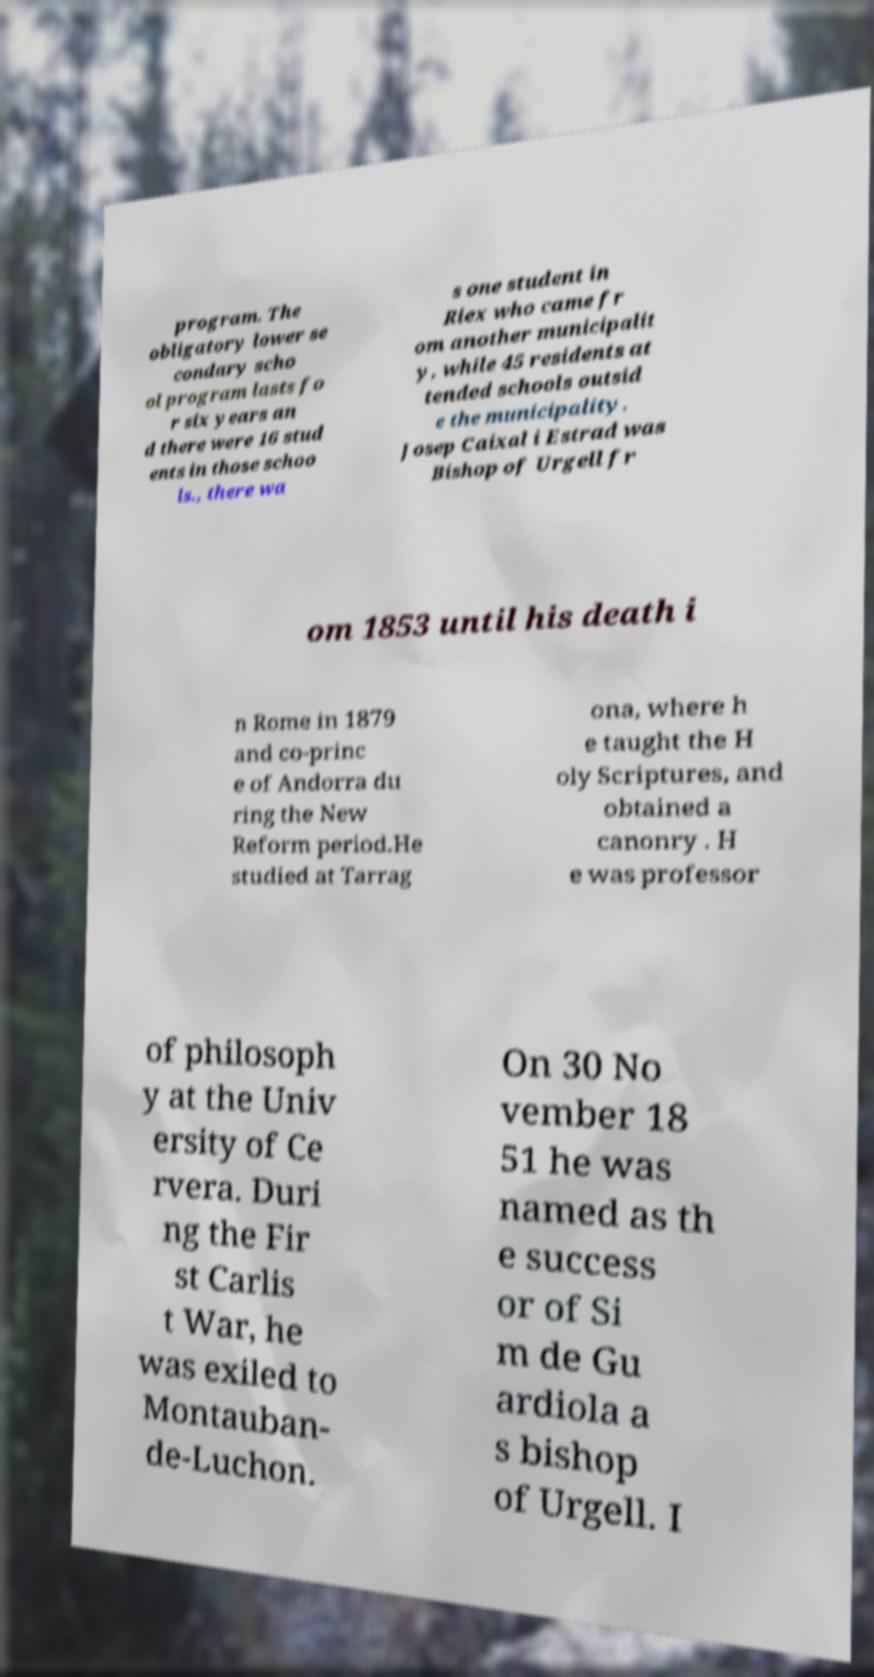Can you read and provide the text displayed in the image?This photo seems to have some interesting text. Can you extract and type it out for me? program. The obligatory lower se condary scho ol program lasts fo r six years an d there were 16 stud ents in those schoo ls., there wa s one student in Riex who came fr om another municipalit y, while 45 residents at tended schools outsid e the municipality. Josep Caixal i Estrad was Bishop of Urgell fr om 1853 until his death i n Rome in 1879 and co-princ e of Andorra du ring the New Reform period.He studied at Tarrag ona, where h e taught the H oly Scriptures, and obtained a canonry . H e was professor of philosoph y at the Univ ersity of Ce rvera. Duri ng the Fir st Carlis t War, he was exiled to Montauban- de-Luchon. On 30 No vember 18 51 he was named as th e success or of Si m de Gu ardiola a s bishop of Urgell. I 